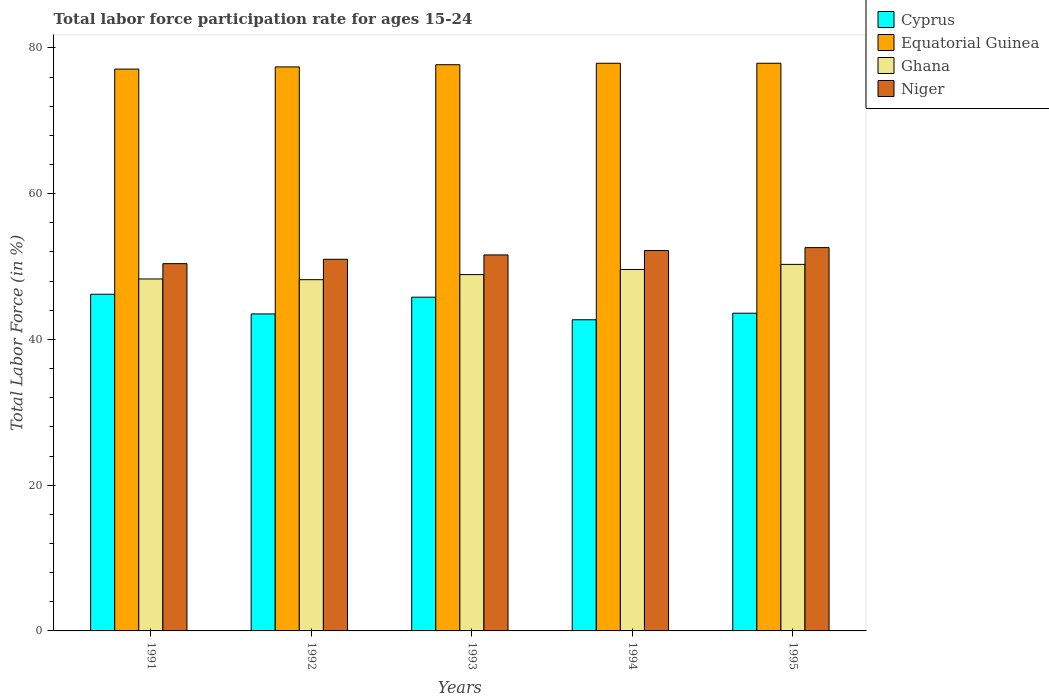How many different coloured bars are there?
Your answer should be compact. 4. How many groups of bars are there?
Provide a short and direct response. 5. Are the number of bars per tick equal to the number of legend labels?
Your answer should be very brief. Yes. Are the number of bars on each tick of the X-axis equal?
Give a very brief answer. Yes. How many bars are there on the 2nd tick from the left?
Ensure brevity in your answer.  4. How many bars are there on the 4th tick from the right?
Provide a succinct answer. 4. What is the label of the 5th group of bars from the left?
Keep it short and to the point. 1995. What is the labor force participation rate in Niger in 1995?
Your response must be concise. 52.6. Across all years, what is the maximum labor force participation rate in Niger?
Offer a very short reply. 52.6. Across all years, what is the minimum labor force participation rate in Niger?
Provide a short and direct response. 50.4. In which year was the labor force participation rate in Cyprus maximum?
Your answer should be compact. 1991. What is the total labor force participation rate in Niger in the graph?
Give a very brief answer. 257.8. What is the difference between the labor force participation rate in Equatorial Guinea in 1993 and that in 1995?
Provide a short and direct response. -0.2. What is the difference between the labor force participation rate in Ghana in 1992 and the labor force participation rate in Niger in 1993?
Provide a short and direct response. -3.4. What is the average labor force participation rate in Equatorial Guinea per year?
Your answer should be very brief. 77.6. In the year 1994, what is the difference between the labor force participation rate in Ghana and labor force participation rate in Cyprus?
Provide a short and direct response. 6.9. What is the ratio of the labor force participation rate in Cyprus in 1992 to that in 1995?
Keep it short and to the point. 1. Is the labor force participation rate in Ghana in 1993 less than that in 1994?
Keep it short and to the point. Yes. Is the difference between the labor force participation rate in Ghana in 1991 and 1995 greater than the difference between the labor force participation rate in Cyprus in 1991 and 1995?
Provide a succinct answer. No. What is the difference between the highest and the second highest labor force participation rate in Cyprus?
Offer a very short reply. 0.4. What is the difference between the highest and the lowest labor force participation rate in Ghana?
Ensure brevity in your answer.  2.1. In how many years, is the labor force participation rate in Cyprus greater than the average labor force participation rate in Cyprus taken over all years?
Ensure brevity in your answer.  2. Is the sum of the labor force participation rate in Equatorial Guinea in 1991 and 1994 greater than the maximum labor force participation rate in Cyprus across all years?
Your answer should be compact. Yes. What does the 1st bar from the right in 1994 represents?
Provide a succinct answer. Niger. Is it the case that in every year, the sum of the labor force participation rate in Niger and labor force participation rate in Cyprus is greater than the labor force participation rate in Equatorial Guinea?
Make the answer very short. Yes. Are all the bars in the graph horizontal?
Your response must be concise. No. How many years are there in the graph?
Your response must be concise. 5. Are the values on the major ticks of Y-axis written in scientific E-notation?
Give a very brief answer. No. Does the graph contain grids?
Your response must be concise. No. How are the legend labels stacked?
Provide a succinct answer. Vertical. What is the title of the graph?
Keep it short and to the point. Total labor force participation rate for ages 15-24. Does "Romania" appear as one of the legend labels in the graph?
Provide a succinct answer. No. What is the Total Labor Force (in %) in Cyprus in 1991?
Provide a short and direct response. 46.2. What is the Total Labor Force (in %) in Equatorial Guinea in 1991?
Provide a succinct answer. 77.1. What is the Total Labor Force (in %) in Ghana in 1991?
Make the answer very short. 48.3. What is the Total Labor Force (in %) in Niger in 1991?
Offer a terse response. 50.4. What is the Total Labor Force (in %) in Cyprus in 1992?
Offer a very short reply. 43.5. What is the Total Labor Force (in %) of Equatorial Guinea in 1992?
Your response must be concise. 77.4. What is the Total Labor Force (in %) of Ghana in 1992?
Keep it short and to the point. 48.2. What is the Total Labor Force (in %) in Niger in 1992?
Your answer should be very brief. 51. What is the Total Labor Force (in %) of Cyprus in 1993?
Provide a succinct answer. 45.8. What is the Total Labor Force (in %) of Equatorial Guinea in 1993?
Offer a very short reply. 77.7. What is the Total Labor Force (in %) of Ghana in 1993?
Provide a short and direct response. 48.9. What is the Total Labor Force (in %) in Niger in 1993?
Offer a very short reply. 51.6. What is the Total Labor Force (in %) of Cyprus in 1994?
Give a very brief answer. 42.7. What is the Total Labor Force (in %) in Equatorial Guinea in 1994?
Provide a short and direct response. 77.9. What is the Total Labor Force (in %) in Ghana in 1994?
Your response must be concise. 49.6. What is the Total Labor Force (in %) of Niger in 1994?
Keep it short and to the point. 52.2. What is the Total Labor Force (in %) in Cyprus in 1995?
Provide a short and direct response. 43.6. What is the Total Labor Force (in %) in Equatorial Guinea in 1995?
Ensure brevity in your answer.  77.9. What is the Total Labor Force (in %) in Ghana in 1995?
Give a very brief answer. 50.3. What is the Total Labor Force (in %) in Niger in 1995?
Offer a very short reply. 52.6. Across all years, what is the maximum Total Labor Force (in %) in Cyprus?
Provide a succinct answer. 46.2. Across all years, what is the maximum Total Labor Force (in %) in Equatorial Guinea?
Give a very brief answer. 77.9. Across all years, what is the maximum Total Labor Force (in %) of Ghana?
Ensure brevity in your answer.  50.3. Across all years, what is the maximum Total Labor Force (in %) of Niger?
Your answer should be very brief. 52.6. Across all years, what is the minimum Total Labor Force (in %) of Cyprus?
Your answer should be very brief. 42.7. Across all years, what is the minimum Total Labor Force (in %) of Equatorial Guinea?
Give a very brief answer. 77.1. Across all years, what is the minimum Total Labor Force (in %) of Ghana?
Provide a succinct answer. 48.2. Across all years, what is the minimum Total Labor Force (in %) of Niger?
Offer a terse response. 50.4. What is the total Total Labor Force (in %) in Cyprus in the graph?
Your answer should be compact. 221.8. What is the total Total Labor Force (in %) in Equatorial Guinea in the graph?
Ensure brevity in your answer.  388. What is the total Total Labor Force (in %) of Ghana in the graph?
Make the answer very short. 245.3. What is the total Total Labor Force (in %) in Niger in the graph?
Provide a succinct answer. 257.8. What is the difference between the Total Labor Force (in %) of Cyprus in 1991 and that in 1992?
Your answer should be very brief. 2.7. What is the difference between the Total Labor Force (in %) of Niger in 1991 and that in 1992?
Provide a short and direct response. -0.6. What is the difference between the Total Labor Force (in %) in Equatorial Guinea in 1991 and that in 1993?
Offer a very short reply. -0.6. What is the difference between the Total Labor Force (in %) of Ghana in 1991 and that in 1993?
Offer a terse response. -0.6. What is the difference between the Total Labor Force (in %) of Cyprus in 1991 and that in 1994?
Offer a terse response. 3.5. What is the difference between the Total Labor Force (in %) in Equatorial Guinea in 1991 and that in 1994?
Offer a very short reply. -0.8. What is the difference between the Total Labor Force (in %) of Ghana in 1991 and that in 1994?
Give a very brief answer. -1.3. What is the difference between the Total Labor Force (in %) of Niger in 1991 and that in 1994?
Your answer should be compact. -1.8. What is the difference between the Total Labor Force (in %) of Equatorial Guinea in 1991 and that in 1995?
Provide a succinct answer. -0.8. What is the difference between the Total Labor Force (in %) of Ghana in 1991 and that in 1995?
Offer a very short reply. -2. What is the difference between the Total Labor Force (in %) in Niger in 1991 and that in 1995?
Make the answer very short. -2.2. What is the difference between the Total Labor Force (in %) of Niger in 1992 and that in 1993?
Offer a very short reply. -0.6. What is the difference between the Total Labor Force (in %) of Cyprus in 1992 and that in 1994?
Ensure brevity in your answer.  0.8. What is the difference between the Total Labor Force (in %) in Niger in 1992 and that in 1994?
Offer a terse response. -1.2. What is the difference between the Total Labor Force (in %) of Ghana in 1992 and that in 1995?
Offer a very short reply. -2.1. What is the difference between the Total Labor Force (in %) in Cyprus in 1993 and that in 1994?
Keep it short and to the point. 3.1. What is the difference between the Total Labor Force (in %) of Equatorial Guinea in 1993 and that in 1995?
Provide a succinct answer. -0.2. What is the difference between the Total Labor Force (in %) of Equatorial Guinea in 1994 and that in 1995?
Your response must be concise. 0. What is the difference between the Total Labor Force (in %) of Cyprus in 1991 and the Total Labor Force (in %) of Equatorial Guinea in 1992?
Your answer should be compact. -31.2. What is the difference between the Total Labor Force (in %) of Equatorial Guinea in 1991 and the Total Labor Force (in %) of Ghana in 1992?
Make the answer very short. 28.9. What is the difference between the Total Labor Force (in %) of Equatorial Guinea in 1991 and the Total Labor Force (in %) of Niger in 1992?
Make the answer very short. 26.1. What is the difference between the Total Labor Force (in %) of Ghana in 1991 and the Total Labor Force (in %) of Niger in 1992?
Keep it short and to the point. -2.7. What is the difference between the Total Labor Force (in %) of Cyprus in 1991 and the Total Labor Force (in %) of Equatorial Guinea in 1993?
Your answer should be very brief. -31.5. What is the difference between the Total Labor Force (in %) of Cyprus in 1991 and the Total Labor Force (in %) of Niger in 1993?
Give a very brief answer. -5.4. What is the difference between the Total Labor Force (in %) in Equatorial Guinea in 1991 and the Total Labor Force (in %) in Ghana in 1993?
Ensure brevity in your answer.  28.2. What is the difference between the Total Labor Force (in %) of Equatorial Guinea in 1991 and the Total Labor Force (in %) of Niger in 1993?
Your answer should be very brief. 25.5. What is the difference between the Total Labor Force (in %) of Cyprus in 1991 and the Total Labor Force (in %) of Equatorial Guinea in 1994?
Ensure brevity in your answer.  -31.7. What is the difference between the Total Labor Force (in %) of Cyprus in 1991 and the Total Labor Force (in %) of Niger in 1994?
Offer a terse response. -6. What is the difference between the Total Labor Force (in %) of Equatorial Guinea in 1991 and the Total Labor Force (in %) of Ghana in 1994?
Offer a very short reply. 27.5. What is the difference between the Total Labor Force (in %) of Equatorial Guinea in 1991 and the Total Labor Force (in %) of Niger in 1994?
Make the answer very short. 24.9. What is the difference between the Total Labor Force (in %) of Cyprus in 1991 and the Total Labor Force (in %) of Equatorial Guinea in 1995?
Ensure brevity in your answer.  -31.7. What is the difference between the Total Labor Force (in %) of Cyprus in 1991 and the Total Labor Force (in %) of Ghana in 1995?
Offer a very short reply. -4.1. What is the difference between the Total Labor Force (in %) of Cyprus in 1991 and the Total Labor Force (in %) of Niger in 1995?
Keep it short and to the point. -6.4. What is the difference between the Total Labor Force (in %) in Equatorial Guinea in 1991 and the Total Labor Force (in %) in Ghana in 1995?
Provide a short and direct response. 26.8. What is the difference between the Total Labor Force (in %) in Equatorial Guinea in 1991 and the Total Labor Force (in %) in Niger in 1995?
Give a very brief answer. 24.5. What is the difference between the Total Labor Force (in %) in Cyprus in 1992 and the Total Labor Force (in %) in Equatorial Guinea in 1993?
Make the answer very short. -34.2. What is the difference between the Total Labor Force (in %) of Cyprus in 1992 and the Total Labor Force (in %) of Ghana in 1993?
Provide a succinct answer. -5.4. What is the difference between the Total Labor Force (in %) in Equatorial Guinea in 1992 and the Total Labor Force (in %) in Ghana in 1993?
Offer a terse response. 28.5. What is the difference between the Total Labor Force (in %) in Equatorial Guinea in 1992 and the Total Labor Force (in %) in Niger in 1993?
Your answer should be very brief. 25.8. What is the difference between the Total Labor Force (in %) of Ghana in 1992 and the Total Labor Force (in %) of Niger in 1993?
Your answer should be very brief. -3.4. What is the difference between the Total Labor Force (in %) in Cyprus in 1992 and the Total Labor Force (in %) in Equatorial Guinea in 1994?
Your response must be concise. -34.4. What is the difference between the Total Labor Force (in %) in Cyprus in 1992 and the Total Labor Force (in %) in Ghana in 1994?
Keep it short and to the point. -6.1. What is the difference between the Total Labor Force (in %) in Cyprus in 1992 and the Total Labor Force (in %) in Niger in 1994?
Offer a terse response. -8.7. What is the difference between the Total Labor Force (in %) in Equatorial Guinea in 1992 and the Total Labor Force (in %) in Ghana in 1994?
Make the answer very short. 27.8. What is the difference between the Total Labor Force (in %) of Equatorial Guinea in 1992 and the Total Labor Force (in %) of Niger in 1994?
Make the answer very short. 25.2. What is the difference between the Total Labor Force (in %) of Ghana in 1992 and the Total Labor Force (in %) of Niger in 1994?
Keep it short and to the point. -4. What is the difference between the Total Labor Force (in %) of Cyprus in 1992 and the Total Labor Force (in %) of Equatorial Guinea in 1995?
Offer a very short reply. -34.4. What is the difference between the Total Labor Force (in %) in Equatorial Guinea in 1992 and the Total Labor Force (in %) in Ghana in 1995?
Offer a very short reply. 27.1. What is the difference between the Total Labor Force (in %) of Equatorial Guinea in 1992 and the Total Labor Force (in %) of Niger in 1995?
Give a very brief answer. 24.8. What is the difference between the Total Labor Force (in %) of Cyprus in 1993 and the Total Labor Force (in %) of Equatorial Guinea in 1994?
Your answer should be very brief. -32.1. What is the difference between the Total Labor Force (in %) of Cyprus in 1993 and the Total Labor Force (in %) of Ghana in 1994?
Keep it short and to the point. -3.8. What is the difference between the Total Labor Force (in %) of Equatorial Guinea in 1993 and the Total Labor Force (in %) of Ghana in 1994?
Your answer should be compact. 28.1. What is the difference between the Total Labor Force (in %) of Cyprus in 1993 and the Total Labor Force (in %) of Equatorial Guinea in 1995?
Offer a very short reply. -32.1. What is the difference between the Total Labor Force (in %) of Equatorial Guinea in 1993 and the Total Labor Force (in %) of Ghana in 1995?
Make the answer very short. 27.4. What is the difference between the Total Labor Force (in %) in Equatorial Guinea in 1993 and the Total Labor Force (in %) in Niger in 1995?
Provide a succinct answer. 25.1. What is the difference between the Total Labor Force (in %) of Cyprus in 1994 and the Total Labor Force (in %) of Equatorial Guinea in 1995?
Keep it short and to the point. -35.2. What is the difference between the Total Labor Force (in %) in Equatorial Guinea in 1994 and the Total Labor Force (in %) in Ghana in 1995?
Your response must be concise. 27.6. What is the difference between the Total Labor Force (in %) of Equatorial Guinea in 1994 and the Total Labor Force (in %) of Niger in 1995?
Provide a succinct answer. 25.3. What is the average Total Labor Force (in %) of Cyprus per year?
Provide a short and direct response. 44.36. What is the average Total Labor Force (in %) in Equatorial Guinea per year?
Your answer should be compact. 77.6. What is the average Total Labor Force (in %) of Ghana per year?
Your response must be concise. 49.06. What is the average Total Labor Force (in %) of Niger per year?
Make the answer very short. 51.56. In the year 1991, what is the difference between the Total Labor Force (in %) in Cyprus and Total Labor Force (in %) in Equatorial Guinea?
Offer a very short reply. -30.9. In the year 1991, what is the difference between the Total Labor Force (in %) of Cyprus and Total Labor Force (in %) of Ghana?
Ensure brevity in your answer.  -2.1. In the year 1991, what is the difference between the Total Labor Force (in %) of Equatorial Guinea and Total Labor Force (in %) of Ghana?
Your response must be concise. 28.8. In the year 1991, what is the difference between the Total Labor Force (in %) of Equatorial Guinea and Total Labor Force (in %) of Niger?
Give a very brief answer. 26.7. In the year 1992, what is the difference between the Total Labor Force (in %) in Cyprus and Total Labor Force (in %) in Equatorial Guinea?
Your answer should be compact. -33.9. In the year 1992, what is the difference between the Total Labor Force (in %) in Equatorial Guinea and Total Labor Force (in %) in Ghana?
Make the answer very short. 29.2. In the year 1992, what is the difference between the Total Labor Force (in %) of Equatorial Guinea and Total Labor Force (in %) of Niger?
Offer a terse response. 26.4. In the year 1992, what is the difference between the Total Labor Force (in %) in Ghana and Total Labor Force (in %) in Niger?
Your answer should be compact. -2.8. In the year 1993, what is the difference between the Total Labor Force (in %) in Cyprus and Total Labor Force (in %) in Equatorial Guinea?
Keep it short and to the point. -31.9. In the year 1993, what is the difference between the Total Labor Force (in %) in Cyprus and Total Labor Force (in %) in Niger?
Provide a short and direct response. -5.8. In the year 1993, what is the difference between the Total Labor Force (in %) of Equatorial Guinea and Total Labor Force (in %) of Ghana?
Your response must be concise. 28.8. In the year 1993, what is the difference between the Total Labor Force (in %) in Equatorial Guinea and Total Labor Force (in %) in Niger?
Offer a very short reply. 26.1. In the year 1993, what is the difference between the Total Labor Force (in %) in Ghana and Total Labor Force (in %) in Niger?
Ensure brevity in your answer.  -2.7. In the year 1994, what is the difference between the Total Labor Force (in %) of Cyprus and Total Labor Force (in %) of Equatorial Guinea?
Give a very brief answer. -35.2. In the year 1994, what is the difference between the Total Labor Force (in %) of Cyprus and Total Labor Force (in %) of Ghana?
Provide a succinct answer. -6.9. In the year 1994, what is the difference between the Total Labor Force (in %) in Cyprus and Total Labor Force (in %) in Niger?
Offer a very short reply. -9.5. In the year 1994, what is the difference between the Total Labor Force (in %) of Equatorial Guinea and Total Labor Force (in %) of Ghana?
Ensure brevity in your answer.  28.3. In the year 1994, what is the difference between the Total Labor Force (in %) in Equatorial Guinea and Total Labor Force (in %) in Niger?
Ensure brevity in your answer.  25.7. In the year 1994, what is the difference between the Total Labor Force (in %) in Ghana and Total Labor Force (in %) in Niger?
Provide a succinct answer. -2.6. In the year 1995, what is the difference between the Total Labor Force (in %) in Cyprus and Total Labor Force (in %) in Equatorial Guinea?
Your answer should be very brief. -34.3. In the year 1995, what is the difference between the Total Labor Force (in %) in Cyprus and Total Labor Force (in %) in Niger?
Your answer should be compact. -9. In the year 1995, what is the difference between the Total Labor Force (in %) of Equatorial Guinea and Total Labor Force (in %) of Ghana?
Your response must be concise. 27.6. In the year 1995, what is the difference between the Total Labor Force (in %) of Equatorial Guinea and Total Labor Force (in %) of Niger?
Ensure brevity in your answer.  25.3. In the year 1995, what is the difference between the Total Labor Force (in %) in Ghana and Total Labor Force (in %) in Niger?
Your answer should be very brief. -2.3. What is the ratio of the Total Labor Force (in %) of Cyprus in 1991 to that in 1992?
Offer a terse response. 1.06. What is the ratio of the Total Labor Force (in %) of Ghana in 1991 to that in 1992?
Your answer should be compact. 1. What is the ratio of the Total Labor Force (in %) in Niger in 1991 to that in 1992?
Ensure brevity in your answer.  0.99. What is the ratio of the Total Labor Force (in %) in Cyprus in 1991 to that in 1993?
Make the answer very short. 1.01. What is the ratio of the Total Labor Force (in %) in Niger in 1991 to that in 1993?
Your answer should be compact. 0.98. What is the ratio of the Total Labor Force (in %) of Cyprus in 1991 to that in 1994?
Keep it short and to the point. 1.08. What is the ratio of the Total Labor Force (in %) of Ghana in 1991 to that in 1994?
Your response must be concise. 0.97. What is the ratio of the Total Labor Force (in %) of Niger in 1991 to that in 1994?
Make the answer very short. 0.97. What is the ratio of the Total Labor Force (in %) of Cyprus in 1991 to that in 1995?
Your response must be concise. 1.06. What is the ratio of the Total Labor Force (in %) in Ghana in 1991 to that in 1995?
Your response must be concise. 0.96. What is the ratio of the Total Labor Force (in %) in Niger in 1991 to that in 1995?
Make the answer very short. 0.96. What is the ratio of the Total Labor Force (in %) in Cyprus in 1992 to that in 1993?
Offer a very short reply. 0.95. What is the ratio of the Total Labor Force (in %) in Ghana in 1992 to that in 1993?
Offer a very short reply. 0.99. What is the ratio of the Total Labor Force (in %) of Niger in 1992 to that in 1993?
Your answer should be compact. 0.99. What is the ratio of the Total Labor Force (in %) of Cyprus in 1992 to that in 1994?
Make the answer very short. 1.02. What is the ratio of the Total Labor Force (in %) in Ghana in 1992 to that in 1994?
Your answer should be compact. 0.97. What is the ratio of the Total Labor Force (in %) in Ghana in 1992 to that in 1995?
Your answer should be very brief. 0.96. What is the ratio of the Total Labor Force (in %) in Niger in 1992 to that in 1995?
Offer a terse response. 0.97. What is the ratio of the Total Labor Force (in %) in Cyprus in 1993 to that in 1994?
Offer a terse response. 1.07. What is the ratio of the Total Labor Force (in %) in Equatorial Guinea in 1993 to that in 1994?
Your answer should be compact. 1. What is the ratio of the Total Labor Force (in %) of Ghana in 1993 to that in 1994?
Provide a succinct answer. 0.99. What is the ratio of the Total Labor Force (in %) in Niger in 1993 to that in 1994?
Your answer should be very brief. 0.99. What is the ratio of the Total Labor Force (in %) in Cyprus in 1993 to that in 1995?
Offer a terse response. 1.05. What is the ratio of the Total Labor Force (in %) in Equatorial Guinea in 1993 to that in 1995?
Your answer should be very brief. 1. What is the ratio of the Total Labor Force (in %) in Ghana in 1993 to that in 1995?
Provide a short and direct response. 0.97. What is the ratio of the Total Labor Force (in %) of Cyprus in 1994 to that in 1995?
Offer a very short reply. 0.98. What is the ratio of the Total Labor Force (in %) in Ghana in 1994 to that in 1995?
Keep it short and to the point. 0.99. What is the ratio of the Total Labor Force (in %) of Niger in 1994 to that in 1995?
Keep it short and to the point. 0.99. What is the difference between the highest and the lowest Total Labor Force (in %) in Equatorial Guinea?
Ensure brevity in your answer.  0.8. What is the difference between the highest and the lowest Total Labor Force (in %) of Niger?
Make the answer very short. 2.2. 